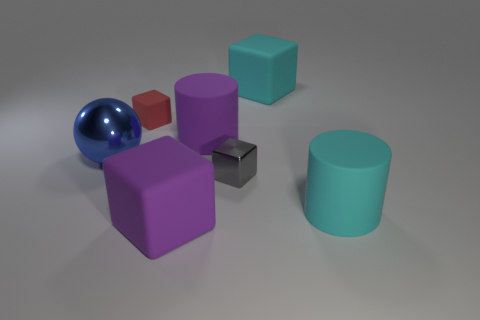Subtract all big cyan cubes. How many cubes are left? 3 Subtract all purple cubes. How many cubes are left? 3 Add 3 large blue cylinders. How many objects exist? 10 Subtract 1 cubes. How many cubes are left? 3 Subtract all balls. How many objects are left? 6 Subtract all red balls. Subtract all red cylinders. How many balls are left? 1 Subtract all small gray metallic blocks. Subtract all small gray blocks. How many objects are left? 5 Add 1 large cyan rubber things. How many large cyan rubber things are left? 3 Add 1 red shiny blocks. How many red shiny blocks exist? 1 Subtract 0 green cylinders. How many objects are left? 7 